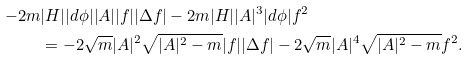Convert formula to latex. <formula><loc_0><loc_0><loc_500><loc_500>- 2 m & | H | | d \phi | | A | | f | | \Delta f | - 2 m | H | | A | ^ { 3 } | d \phi | f ^ { 2 } \\ & = - 2 \sqrt { m } | A | ^ { 2 } \sqrt { | A | ^ { 2 } - m } | f | | \Delta f | - 2 \sqrt { m } | A | ^ { 4 } \sqrt { | A | ^ { 2 } - m } f ^ { 2 } .</formula> 